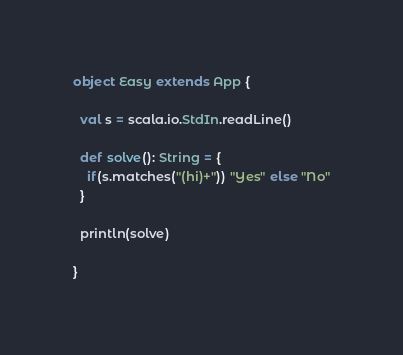Convert code to text. <code><loc_0><loc_0><loc_500><loc_500><_Scala_>object Easy extends App {

  val s = scala.io.StdIn.readLine()

  def solve(): String = {
    if(s.matches("(hi)+")) "Yes" else "No"
  }

  println(solve)

}
</code> 